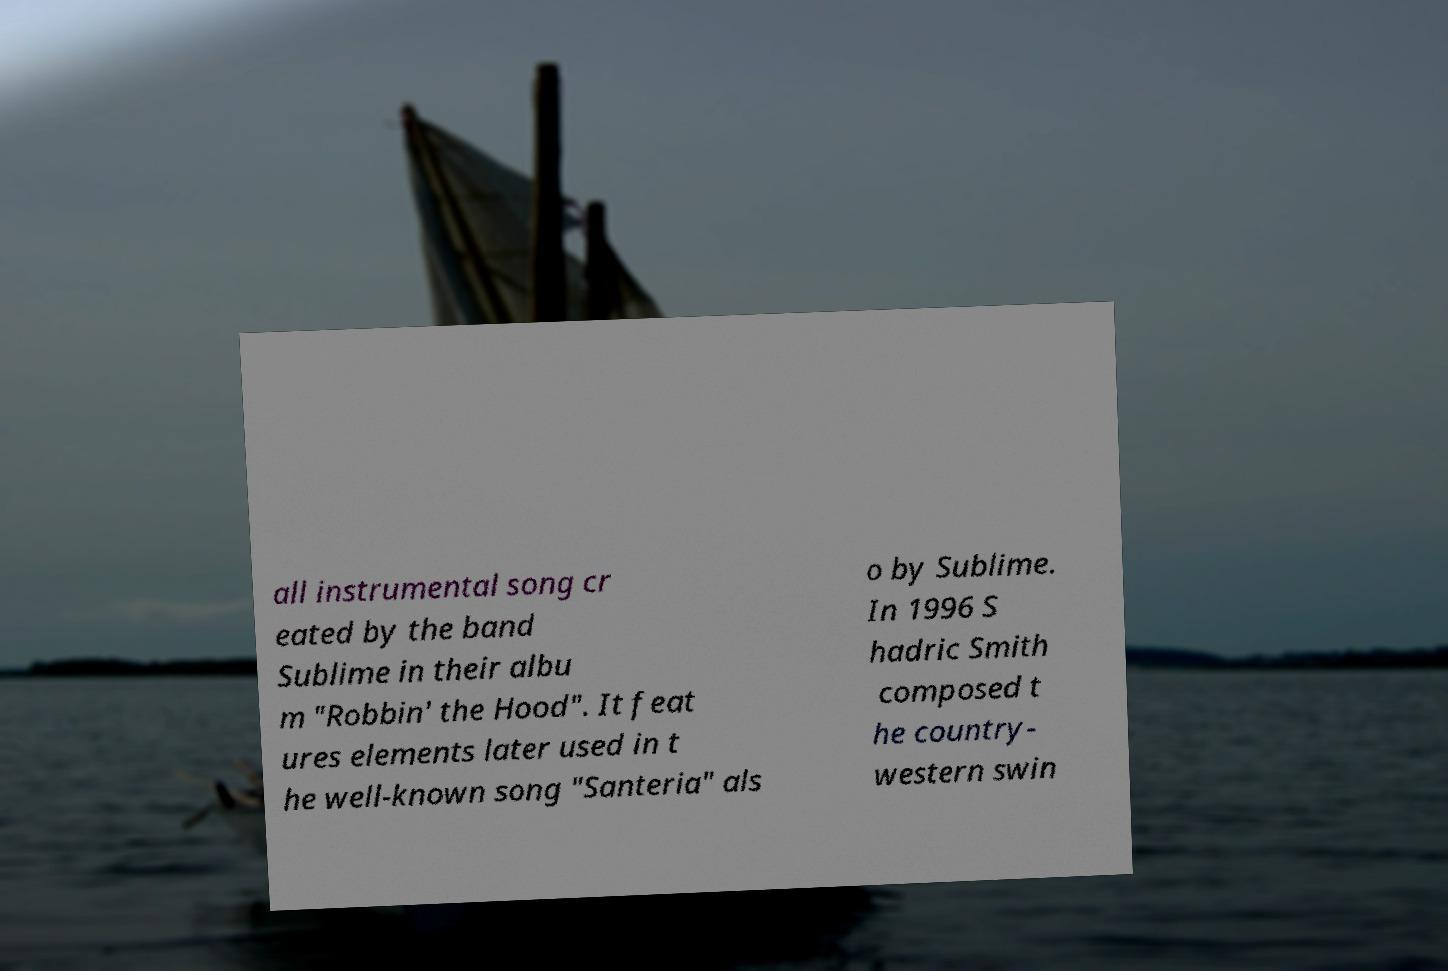For documentation purposes, I need the text within this image transcribed. Could you provide that? all instrumental song cr eated by the band Sublime in their albu m "Robbin' the Hood". It feat ures elements later used in t he well-known song "Santeria" als o by Sublime. In 1996 S hadric Smith composed t he country- western swin 